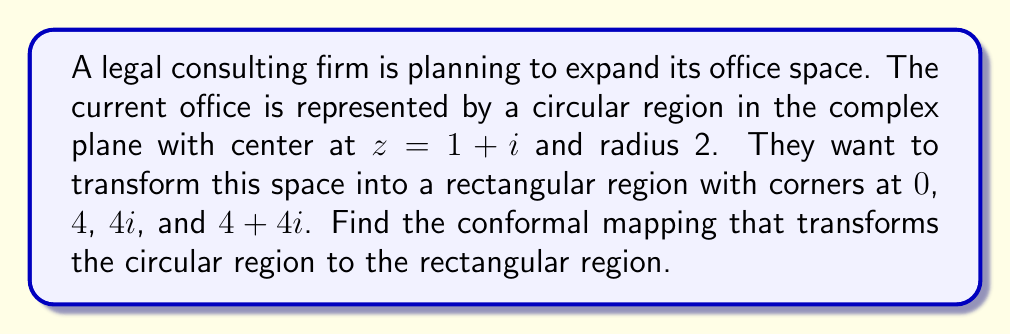Can you solve this math problem? To find the conformal mapping, we'll follow these steps:

1) First, we need to map the circle to the unit circle centered at the origin. This can be done using the transformation:

   $$f_1(z) = \frac{z-(1+i)}{2}$$

2) Next, we need to map the unit circle to the upper half-plane. This can be done using the Möbius transformation:

   $$f_2(z) = i\frac{1+z}{1-z}$$

3) Now, we need to map the upper half-plane to the first quadrant. This can be done using the square root function:

   $$f_3(z) = \sqrt{z}$$

4) Finally, we need to scale and translate the first quadrant to our desired rectangle. This can be done using:

   $$f_4(z) = 4z$$

5) The complete conformal mapping is the composition of these functions:

   $$f(z) = f_4 \circ f_3 \circ f_2 \circ f_1(z)$$

6) Substituting and simplifying:

   $$f(z) = 4\sqrt{i\frac{1+\frac{z-(1+i)}{2}}{1-\frac{z-(1+i)}{2}}}$$

   $$= 4\sqrt{i\frac{z+1-i}{-z+3+i}}$$

   $$= 4\sqrt{i\frac{(z+1-i)(-z+3-i)}{(-z+3+i)(-z+3-i)}}$$

   $$= 4\sqrt{i\frac{-z^2+2z+3-iz+iz+1+i}{z^2-6z+10}}$$

   $$= 4\sqrt{i\frac{-z^2+2z+4+i}{z^2-6z+10}}$$

This is our final conformal mapping.
Answer: The conformal mapping that transforms the given circular region to the rectangular region is:

$$f(z) = 4\sqrt{i\frac{-z^2+2z+4+i}{z^2-6z+10}}$$ 